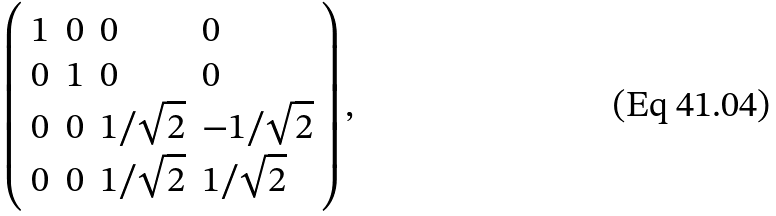Convert formula to latex. <formula><loc_0><loc_0><loc_500><loc_500>\left ( \begin{array} { l l l l } { 1 } & { 0 } & { 0 } & { 0 } \\ { 0 } & { 1 } & { 0 } & { 0 } \\ { 0 } & { 0 } & { { 1 / \sqrt { 2 } } } & { { - 1 / \sqrt { 2 } } } \\ { 0 } & { 0 } & { { 1 / \sqrt { 2 } } } & { { 1 / \sqrt { 2 } } } \end{array} \right ) ,</formula> 